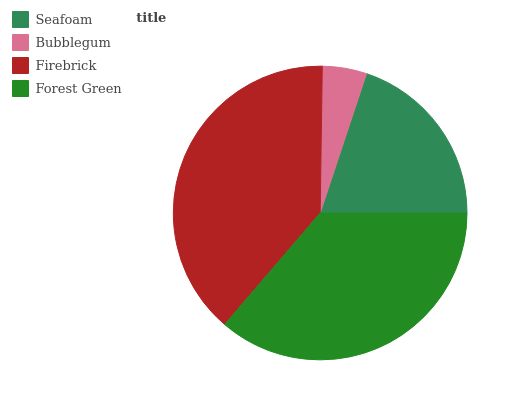Is Bubblegum the minimum?
Answer yes or no. Yes. Is Firebrick the maximum?
Answer yes or no. Yes. Is Firebrick the minimum?
Answer yes or no. No. Is Bubblegum the maximum?
Answer yes or no. No. Is Firebrick greater than Bubblegum?
Answer yes or no. Yes. Is Bubblegum less than Firebrick?
Answer yes or no. Yes. Is Bubblegum greater than Firebrick?
Answer yes or no. No. Is Firebrick less than Bubblegum?
Answer yes or no. No. Is Forest Green the high median?
Answer yes or no. Yes. Is Seafoam the low median?
Answer yes or no. Yes. Is Firebrick the high median?
Answer yes or no. No. Is Forest Green the low median?
Answer yes or no. No. 